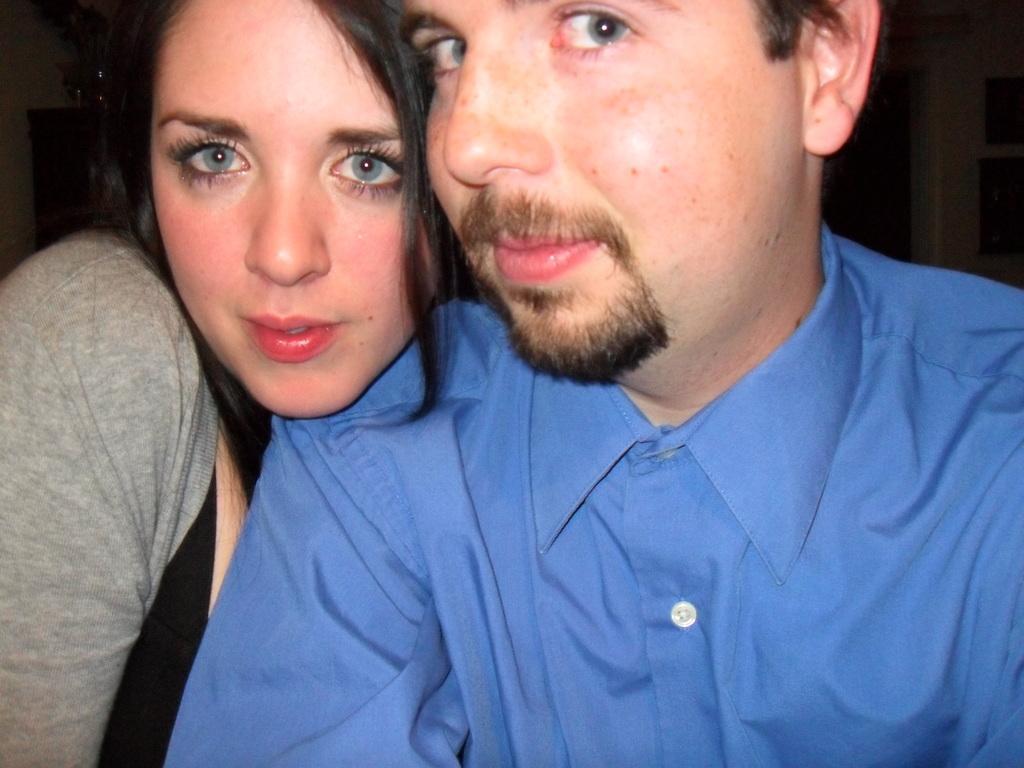How would you summarize this image in a sentence or two? The woman in black T-shirt and grey jacket is standing beside the man who is a wearing blue shirt. Both of them are smiling. I think they are posing for the photo. In the background, it is black in color. 